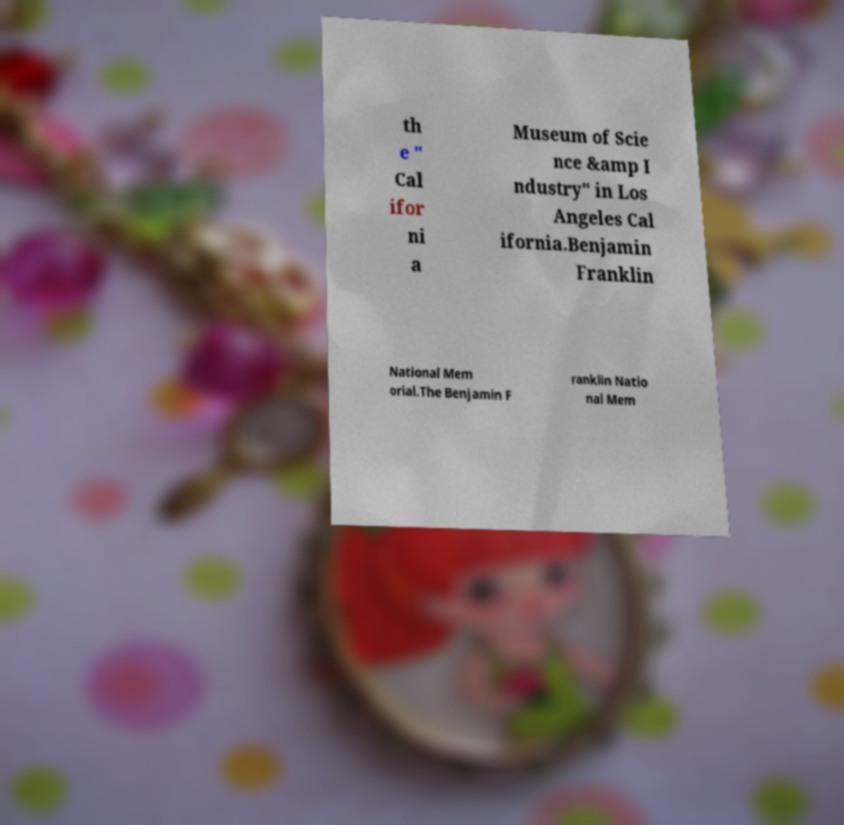Could you extract and type out the text from this image? th e " Cal ifor ni a Museum of Scie nce &amp I ndustry" in Los Angeles Cal ifornia.Benjamin Franklin National Mem orial.The Benjamin F ranklin Natio nal Mem 